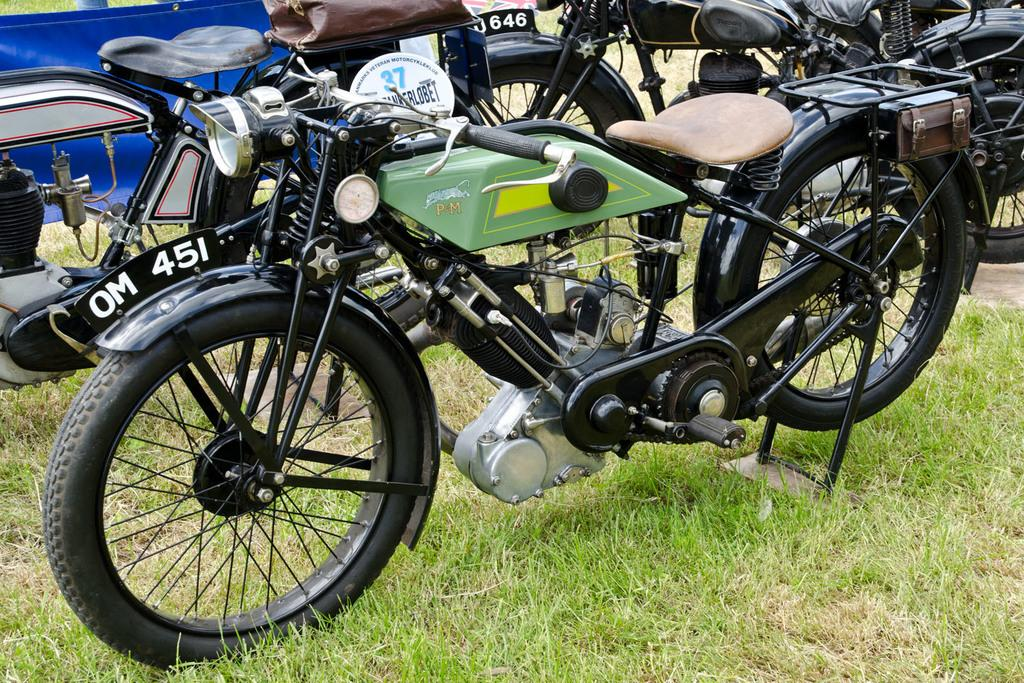What type of surface is at the bottom of the picture? There is grass at the bottom of the picture. What objects are parked in the image? There are three bikes parked in the image. Can you describe the object in the left top of the image? There is a blue sheet in the left top of the image. What type of suit is the band wearing in the image? There is no band or suit present in the image. Which direction is the north located in the image? The image does not provide any information about the direction or location of the north. 